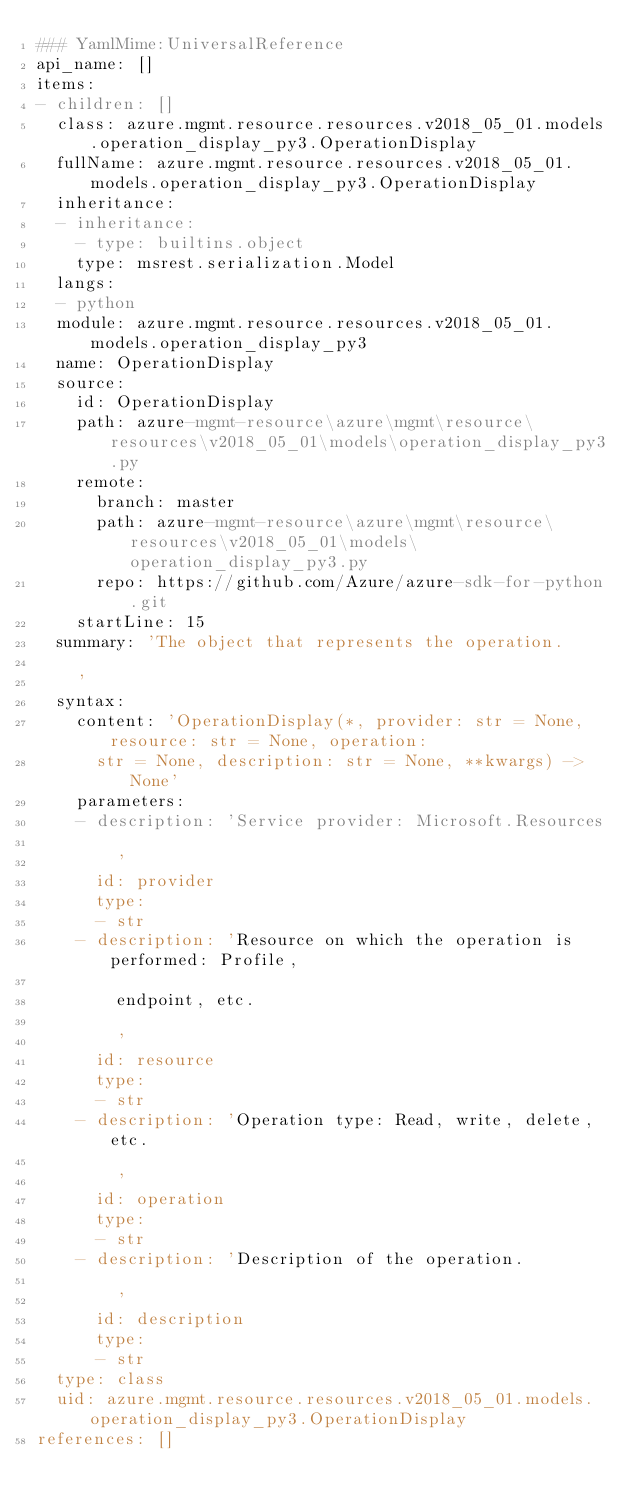Convert code to text. <code><loc_0><loc_0><loc_500><loc_500><_YAML_>### YamlMime:UniversalReference
api_name: []
items:
- children: []
  class: azure.mgmt.resource.resources.v2018_05_01.models.operation_display_py3.OperationDisplay
  fullName: azure.mgmt.resource.resources.v2018_05_01.models.operation_display_py3.OperationDisplay
  inheritance:
  - inheritance:
    - type: builtins.object
    type: msrest.serialization.Model
  langs:
  - python
  module: azure.mgmt.resource.resources.v2018_05_01.models.operation_display_py3
  name: OperationDisplay
  source:
    id: OperationDisplay
    path: azure-mgmt-resource\azure\mgmt\resource\resources\v2018_05_01\models\operation_display_py3.py
    remote:
      branch: master
      path: azure-mgmt-resource\azure\mgmt\resource\resources\v2018_05_01\models\operation_display_py3.py
      repo: https://github.com/Azure/azure-sdk-for-python.git
    startLine: 15
  summary: 'The object that represents the operation.

    '
  syntax:
    content: 'OperationDisplay(*, provider: str = None, resource: str = None, operation:
      str = None, description: str = None, **kwargs) -> None'
    parameters:
    - description: 'Service provider: Microsoft.Resources

        '
      id: provider
      type:
      - str
    - description: 'Resource on which the operation is performed: Profile,

        endpoint, etc.

        '
      id: resource
      type:
      - str
    - description: 'Operation type: Read, write, delete, etc.

        '
      id: operation
      type:
      - str
    - description: 'Description of the operation.

        '
      id: description
      type:
      - str
  type: class
  uid: azure.mgmt.resource.resources.v2018_05_01.models.operation_display_py3.OperationDisplay
references: []
</code> 